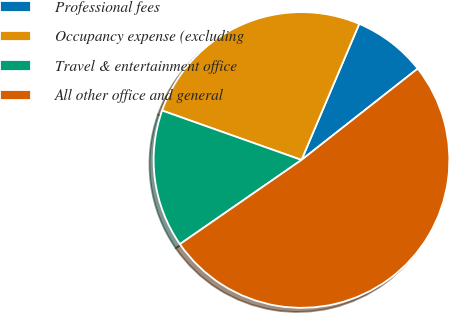Convert chart. <chart><loc_0><loc_0><loc_500><loc_500><pie_chart><fcel>Professional fees<fcel>Occupancy expense (excluding<fcel>Travel & entertainment office<fcel>All other office and general<nl><fcel>8.01%<fcel>25.96%<fcel>15.06%<fcel>50.96%<nl></chart> 